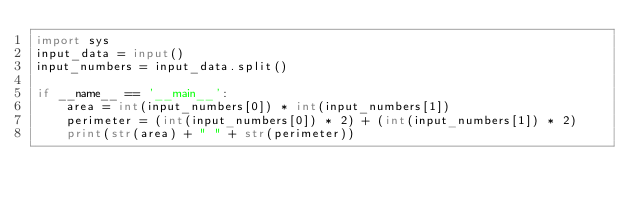<code> <loc_0><loc_0><loc_500><loc_500><_Python_>import sys
input_data = input()
input_numbers = input_data.split()

if __name__ == '__main__':
    area = int(input_numbers[0]) * int(input_numbers[1])
    perimeter = (int(input_numbers[0]) * 2) + (int(input_numbers[1]) * 2)
    print(str(area) + " " + str(perimeter))

</code> 